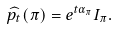<formula> <loc_0><loc_0><loc_500><loc_500>\widehat { p _ { t } } ( \pi ) = e ^ { t \alpha _ { \pi } } I _ { \pi } .</formula> 